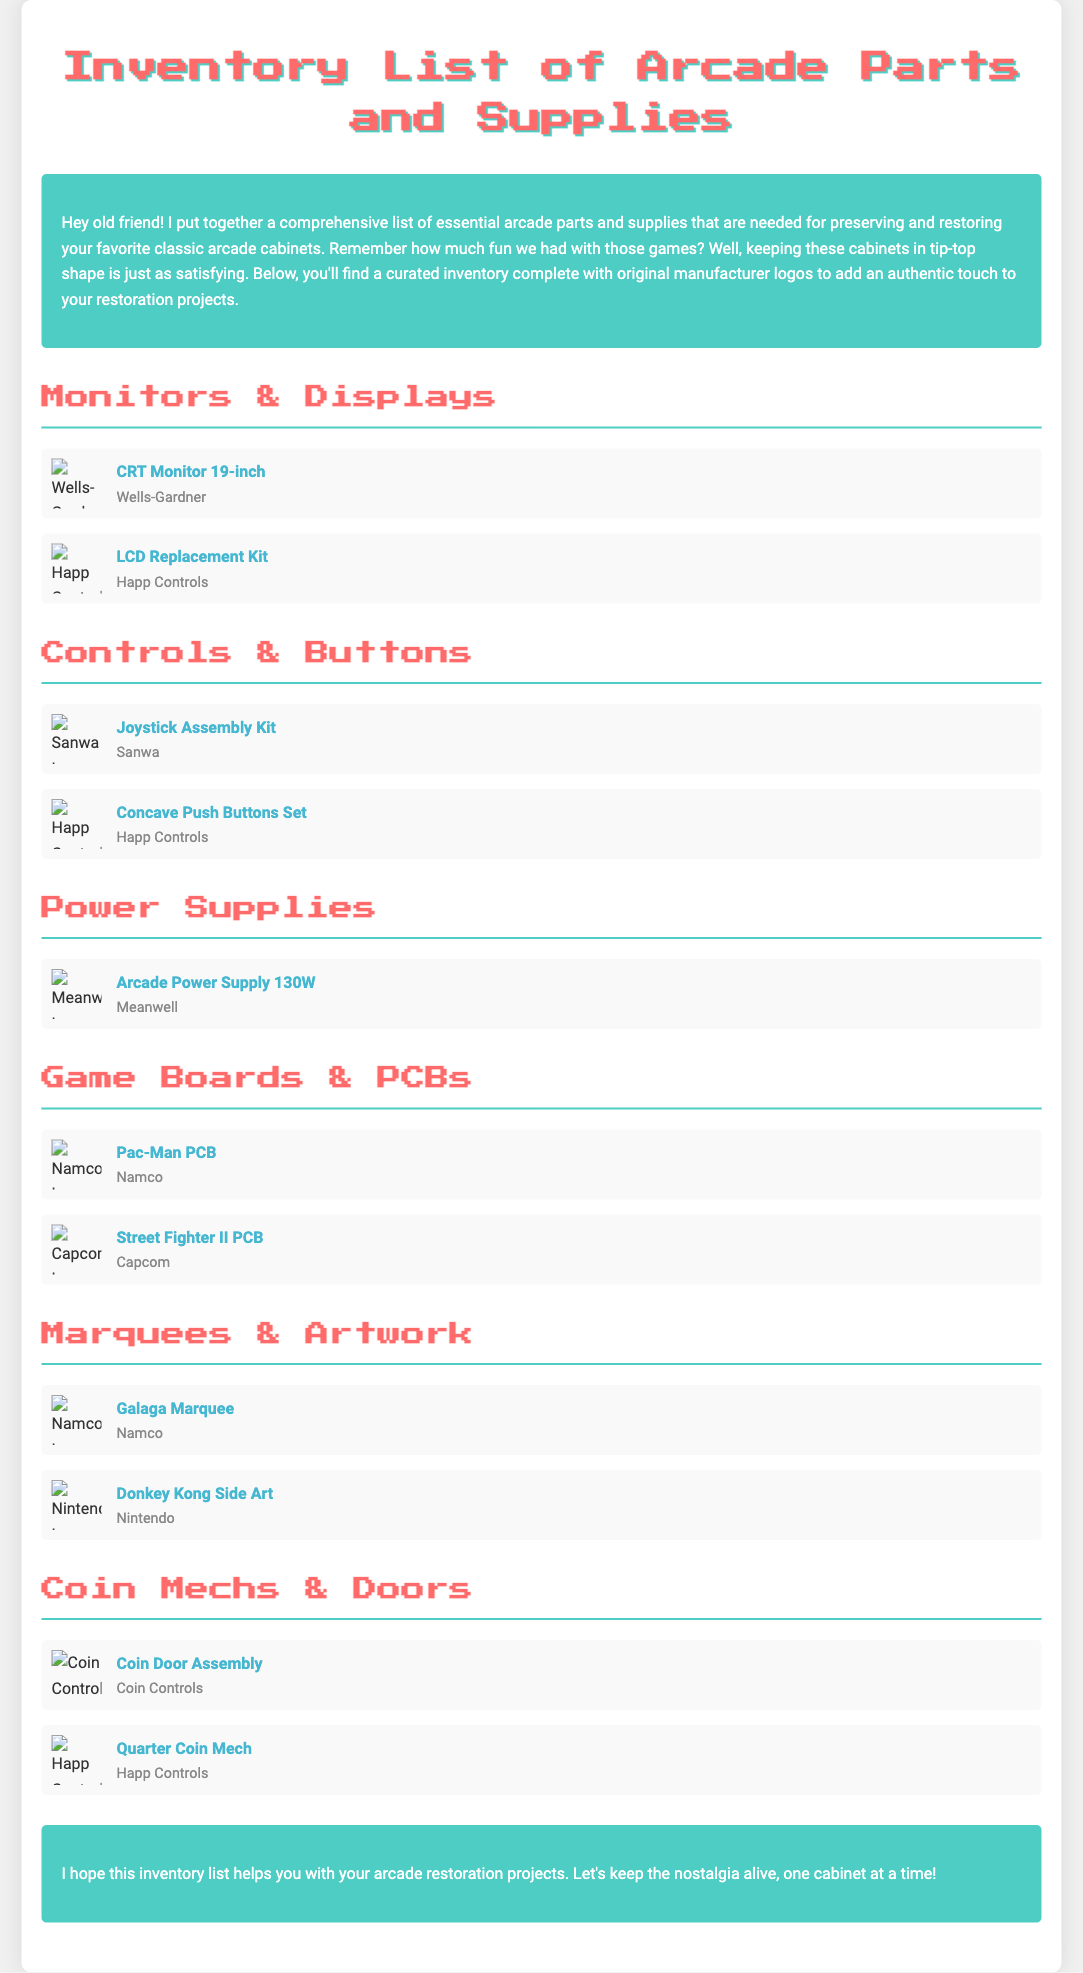What is the title of the document? The title of the document is stated in the header of the webpage as "Inventory List of Arcade Parts and Supplies".
Answer: Inventory List of Arcade Parts and Supplies Who is the manufacturer of the CRT Monitor 19-inch? The manufacturer of the CRT Monitor 19-inch is listed alongside the item name.
Answer: Wells-Gardner How many items are listed under "Game Boards & PCBs"? The number of items under that section can be counted from the listings shown in the document.
Answer: 2 What type of item is the "Galaga Marquee"? The type of item is denoted in the respective section listing.
Answer: Marquee Which company's logo is associated with the Quarterly Coin Mech? The logo is specified alongside the item details in the document.
Answer: Happ Controls What is the total number of sections in the document? The sections can be counted from the layout of the document.
Answer: 6 Which manufacturer produced the Donkey Kong Side Art? The manufacturer is listed directly next to the item in the document.
Answer: Nintendo What color is the footer background? The color is described in the CSS and seen in the document layout.
Answer: Green 